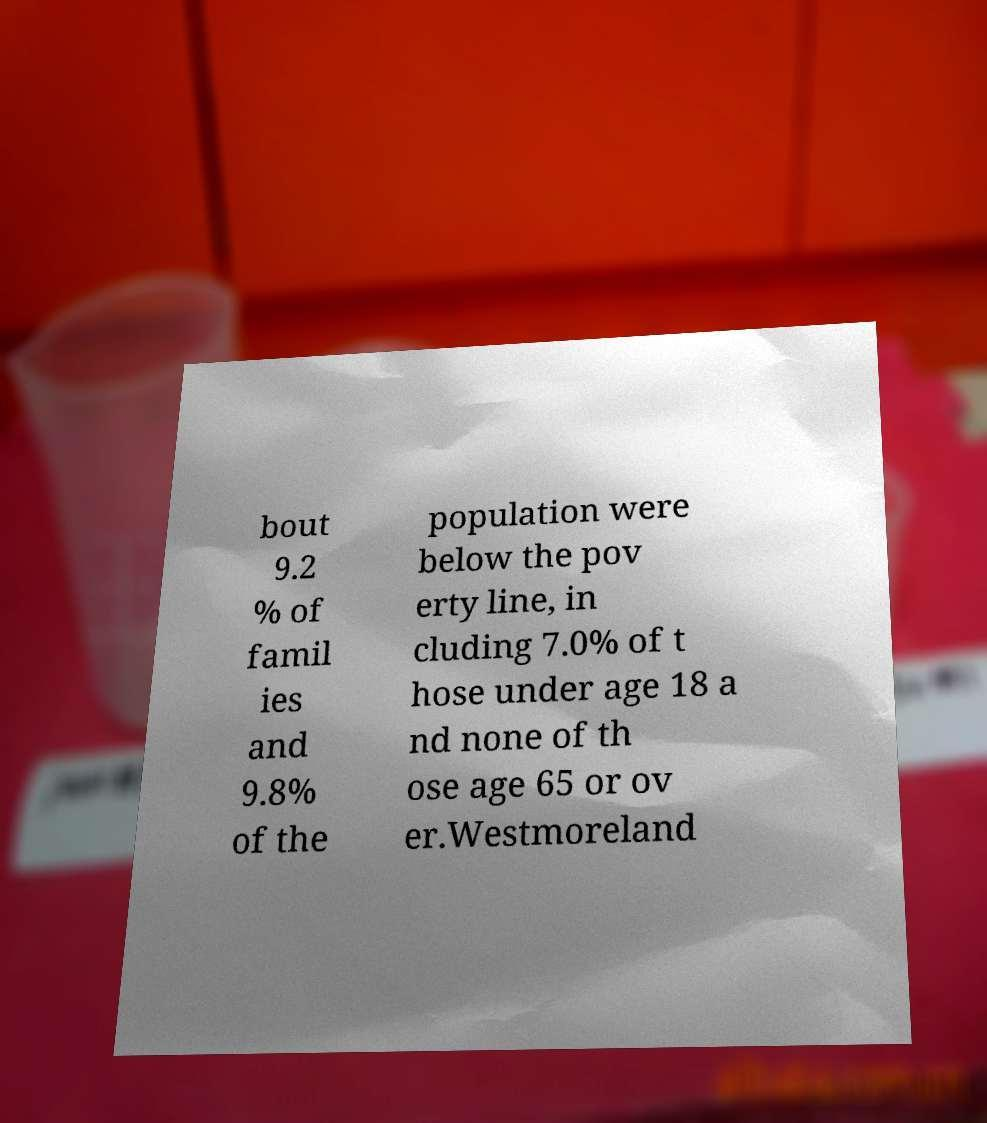I need the written content from this picture converted into text. Can you do that? bout 9.2 % of famil ies and 9.8% of the population were below the pov erty line, in cluding 7.0% of t hose under age 18 a nd none of th ose age 65 or ov er.Westmoreland 